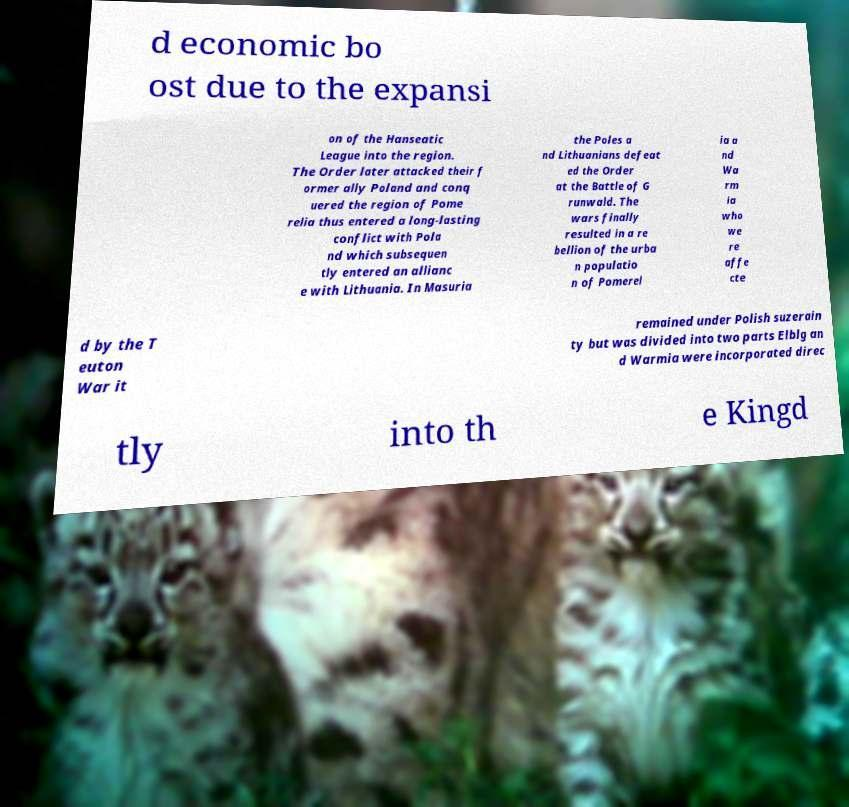Please identify and transcribe the text found in this image. d economic bo ost due to the expansi on of the Hanseatic League into the region. The Order later attacked their f ormer ally Poland and conq uered the region of Pome relia thus entered a long-lasting conflict with Pola nd which subsequen tly entered an allianc e with Lithuania. In Masuria the Poles a nd Lithuanians defeat ed the Order at the Battle of G runwald. The wars finally resulted in a re bellion of the urba n populatio n of Pomerel ia a nd Wa rm ia who we re affe cte d by the T euton War it remained under Polish suzerain ty but was divided into two parts Elblg an d Warmia were incorporated direc tly into th e Kingd 